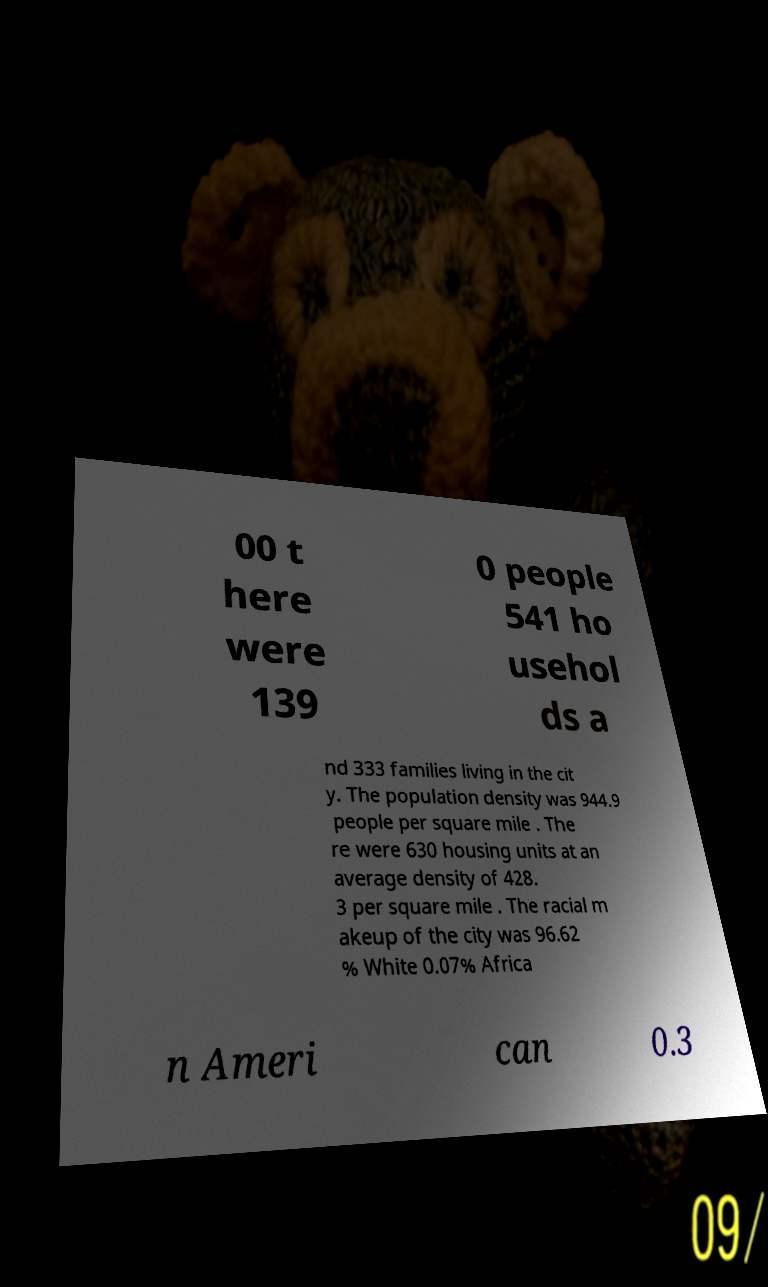For documentation purposes, I need the text within this image transcribed. Could you provide that? 00 t here were 139 0 people 541 ho usehol ds a nd 333 families living in the cit y. The population density was 944.9 people per square mile . The re were 630 housing units at an average density of 428. 3 per square mile . The racial m akeup of the city was 96.62 % White 0.07% Africa n Ameri can 0.3 